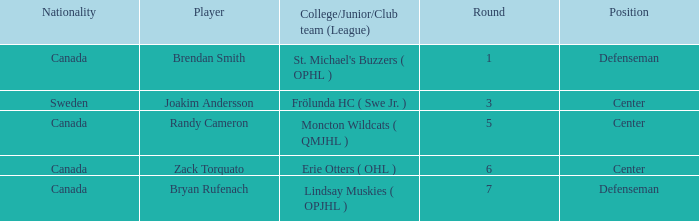What position does Zack Torquato play? Center. 